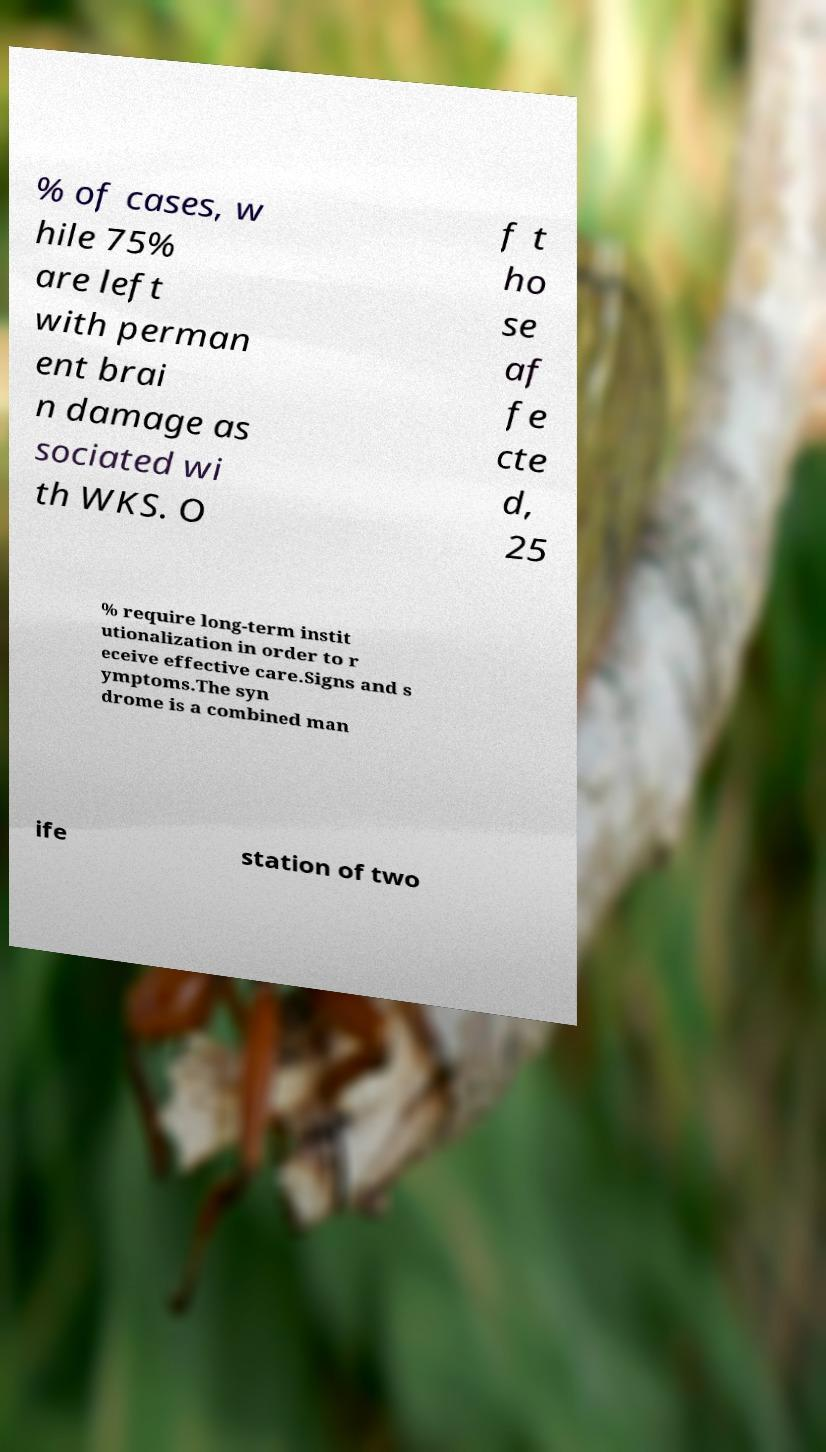Could you assist in decoding the text presented in this image and type it out clearly? % of cases, w hile 75% are left with perman ent brai n damage as sociated wi th WKS. O f t ho se af fe cte d, 25 % require long-term instit utionalization in order to r eceive effective care.Signs and s ymptoms.The syn drome is a combined man ife station of two 